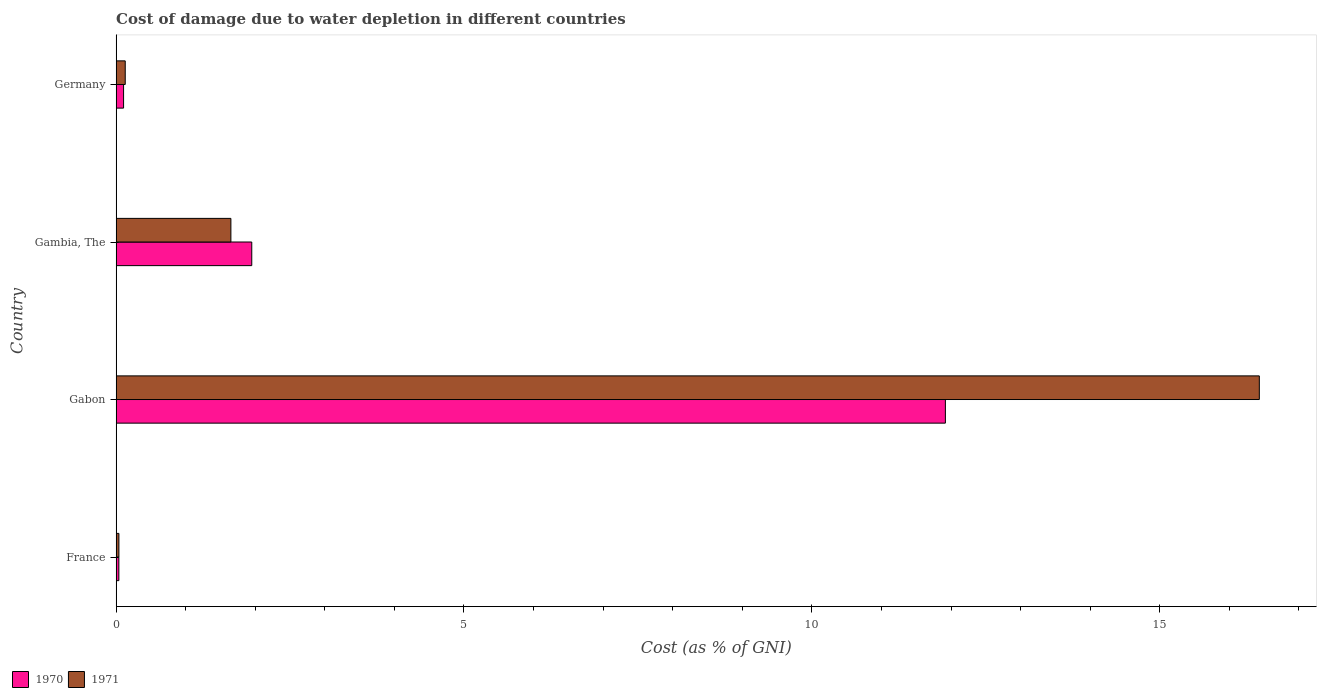How many groups of bars are there?
Ensure brevity in your answer.  4. Are the number of bars on each tick of the Y-axis equal?
Provide a succinct answer. Yes. In how many cases, is the number of bars for a given country not equal to the number of legend labels?
Provide a succinct answer. 0. What is the cost of damage caused due to water depletion in 1971 in Gambia, The?
Offer a terse response. 1.65. Across all countries, what is the maximum cost of damage caused due to water depletion in 1970?
Ensure brevity in your answer.  11.92. Across all countries, what is the minimum cost of damage caused due to water depletion in 1971?
Your answer should be very brief. 0.04. In which country was the cost of damage caused due to water depletion in 1970 maximum?
Your answer should be very brief. Gabon. In which country was the cost of damage caused due to water depletion in 1970 minimum?
Your answer should be very brief. France. What is the total cost of damage caused due to water depletion in 1970 in the graph?
Provide a succinct answer. 14.02. What is the difference between the cost of damage caused due to water depletion in 1971 in Gabon and that in Germany?
Ensure brevity in your answer.  16.3. What is the difference between the cost of damage caused due to water depletion in 1970 in Gambia, The and the cost of damage caused due to water depletion in 1971 in France?
Provide a short and direct response. 1.91. What is the average cost of damage caused due to water depletion in 1970 per country?
Give a very brief answer. 3.5. What is the difference between the cost of damage caused due to water depletion in 1971 and cost of damage caused due to water depletion in 1970 in Gabon?
Give a very brief answer. 4.51. In how many countries, is the cost of damage caused due to water depletion in 1970 greater than 1 %?
Keep it short and to the point. 2. What is the ratio of the cost of damage caused due to water depletion in 1970 in France to that in Gabon?
Your response must be concise. 0. Is the difference between the cost of damage caused due to water depletion in 1971 in France and Germany greater than the difference between the cost of damage caused due to water depletion in 1970 in France and Germany?
Offer a very short reply. No. What is the difference between the highest and the second highest cost of damage caused due to water depletion in 1970?
Offer a very short reply. 9.97. What is the difference between the highest and the lowest cost of damage caused due to water depletion in 1971?
Give a very brief answer. 16.39. What does the 2nd bar from the top in Gabon represents?
Provide a succinct answer. 1970. How many bars are there?
Provide a short and direct response. 8. How many countries are there in the graph?
Offer a very short reply. 4. Are the values on the major ticks of X-axis written in scientific E-notation?
Offer a very short reply. No. Where does the legend appear in the graph?
Your answer should be very brief. Bottom left. How many legend labels are there?
Offer a very short reply. 2. What is the title of the graph?
Give a very brief answer. Cost of damage due to water depletion in different countries. What is the label or title of the X-axis?
Make the answer very short. Cost (as % of GNI). What is the label or title of the Y-axis?
Your response must be concise. Country. What is the Cost (as % of GNI) in 1970 in France?
Keep it short and to the point. 0.04. What is the Cost (as % of GNI) in 1971 in France?
Your response must be concise. 0.04. What is the Cost (as % of GNI) in 1970 in Gabon?
Your answer should be very brief. 11.92. What is the Cost (as % of GNI) of 1971 in Gabon?
Keep it short and to the point. 16.43. What is the Cost (as % of GNI) in 1970 in Gambia, The?
Your answer should be very brief. 1.95. What is the Cost (as % of GNI) in 1971 in Gambia, The?
Keep it short and to the point. 1.65. What is the Cost (as % of GNI) in 1970 in Germany?
Ensure brevity in your answer.  0.11. What is the Cost (as % of GNI) of 1971 in Germany?
Give a very brief answer. 0.13. Across all countries, what is the maximum Cost (as % of GNI) in 1970?
Offer a very short reply. 11.92. Across all countries, what is the maximum Cost (as % of GNI) of 1971?
Provide a short and direct response. 16.43. Across all countries, what is the minimum Cost (as % of GNI) in 1970?
Make the answer very short. 0.04. Across all countries, what is the minimum Cost (as % of GNI) in 1971?
Offer a terse response. 0.04. What is the total Cost (as % of GNI) of 1970 in the graph?
Provide a short and direct response. 14.02. What is the total Cost (as % of GNI) of 1971 in the graph?
Keep it short and to the point. 18.25. What is the difference between the Cost (as % of GNI) of 1970 in France and that in Gabon?
Make the answer very short. -11.88. What is the difference between the Cost (as % of GNI) in 1971 in France and that in Gabon?
Make the answer very short. -16.39. What is the difference between the Cost (as % of GNI) of 1970 in France and that in Gambia, The?
Ensure brevity in your answer.  -1.91. What is the difference between the Cost (as % of GNI) in 1971 in France and that in Gambia, The?
Offer a terse response. -1.61. What is the difference between the Cost (as % of GNI) of 1970 in France and that in Germany?
Your answer should be compact. -0.07. What is the difference between the Cost (as % of GNI) in 1971 in France and that in Germany?
Ensure brevity in your answer.  -0.09. What is the difference between the Cost (as % of GNI) in 1970 in Gabon and that in Gambia, The?
Give a very brief answer. 9.97. What is the difference between the Cost (as % of GNI) in 1971 in Gabon and that in Gambia, The?
Offer a terse response. 14.78. What is the difference between the Cost (as % of GNI) in 1970 in Gabon and that in Germany?
Ensure brevity in your answer.  11.81. What is the difference between the Cost (as % of GNI) in 1971 in Gabon and that in Germany?
Ensure brevity in your answer.  16.3. What is the difference between the Cost (as % of GNI) in 1970 in Gambia, The and that in Germany?
Ensure brevity in your answer.  1.84. What is the difference between the Cost (as % of GNI) in 1971 in Gambia, The and that in Germany?
Keep it short and to the point. 1.52. What is the difference between the Cost (as % of GNI) in 1970 in France and the Cost (as % of GNI) in 1971 in Gabon?
Keep it short and to the point. -16.39. What is the difference between the Cost (as % of GNI) of 1970 in France and the Cost (as % of GNI) of 1971 in Gambia, The?
Offer a terse response. -1.61. What is the difference between the Cost (as % of GNI) in 1970 in France and the Cost (as % of GNI) in 1971 in Germany?
Your response must be concise. -0.09. What is the difference between the Cost (as % of GNI) of 1970 in Gabon and the Cost (as % of GNI) of 1971 in Gambia, The?
Offer a terse response. 10.27. What is the difference between the Cost (as % of GNI) of 1970 in Gabon and the Cost (as % of GNI) of 1971 in Germany?
Your response must be concise. 11.79. What is the difference between the Cost (as % of GNI) of 1970 in Gambia, The and the Cost (as % of GNI) of 1971 in Germany?
Offer a terse response. 1.82. What is the average Cost (as % of GNI) in 1970 per country?
Provide a short and direct response. 3.5. What is the average Cost (as % of GNI) of 1971 per country?
Offer a very short reply. 4.56. What is the difference between the Cost (as % of GNI) of 1970 and Cost (as % of GNI) of 1971 in France?
Offer a very short reply. -0. What is the difference between the Cost (as % of GNI) of 1970 and Cost (as % of GNI) of 1971 in Gabon?
Your answer should be very brief. -4.51. What is the difference between the Cost (as % of GNI) in 1970 and Cost (as % of GNI) in 1971 in Gambia, The?
Offer a very short reply. 0.3. What is the difference between the Cost (as % of GNI) of 1970 and Cost (as % of GNI) of 1971 in Germany?
Give a very brief answer. -0.02. What is the ratio of the Cost (as % of GNI) of 1970 in France to that in Gabon?
Your response must be concise. 0. What is the ratio of the Cost (as % of GNI) in 1971 in France to that in Gabon?
Keep it short and to the point. 0. What is the ratio of the Cost (as % of GNI) in 1970 in France to that in Gambia, The?
Provide a short and direct response. 0.02. What is the ratio of the Cost (as % of GNI) of 1971 in France to that in Gambia, The?
Your response must be concise. 0.02. What is the ratio of the Cost (as % of GNI) of 1970 in France to that in Germany?
Your response must be concise. 0.37. What is the ratio of the Cost (as % of GNI) of 1971 in France to that in Germany?
Offer a very short reply. 0.3. What is the ratio of the Cost (as % of GNI) in 1970 in Gabon to that in Gambia, The?
Your answer should be compact. 6.11. What is the ratio of the Cost (as % of GNI) in 1971 in Gabon to that in Gambia, The?
Provide a short and direct response. 9.96. What is the ratio of the Cost (as % of GNI) in 1970 in Gabon to that in Germany?
Give a very brief answer. 111.24. What is the ratio of the Cost (as % of GNI) of 1971 in Gabon to that in Germany?
Your response must be concise. 125.54. What is the ratio of the Cost (as % of GNI) in 1970 in Gambia, The to that in Germany?
Provide a short and direct response. 18.19. What is the ratio of the Cost (as % of GNI) of 1971 in Gambia, The to that in Germany?
Offer a very short reply. 12.6. What is the difference between the highest and the second highest Cost (as % of GNI) in 1970?
Your answer should be very brief. 9.97. What is the difference between the highest and the second highest Cost (as % of GNI) of 1971?
Give a very brief answer. 14.78. What is the difference between the highest and the lowest Cost (as % of GNI) of 1970?
Offer a very short reply. 11.88. What is the difference between the highest and the lowest Cost (as % of GNI) in 1971?
Offer a very short reply. 16.39. 